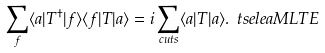<formula> <loc_0><loc_0><loc_500><loc_500>\sum _ { f } \langle a | T ^ { \dag } | f \rangle \langle f | T | a \rangle = i \sum _ { c u t s } \langle a | T | a \rangle . \ t s e l e a { M L T E }</formula> 